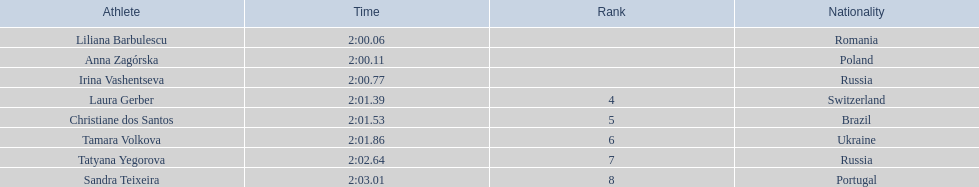What is the name of the top finalist of this semifinals heat? Liliana Barbulescu. 